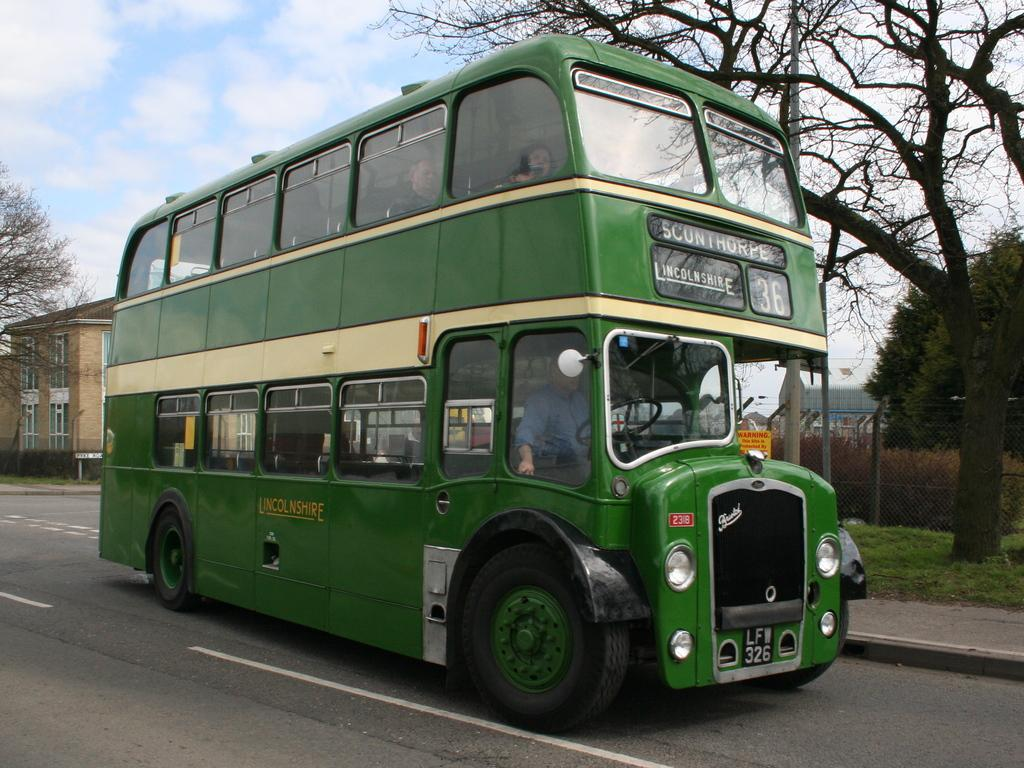Provide a one-sentence caption for the provided image. a green double decker bus number 36 for Lincolnshire. 